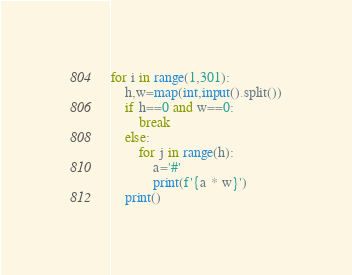<code> <loc_0><loc_0><loc_500><loc_500><_Python_>for i in range(1,301):
    h,w=map(int,input().split())
    if h==0 and w==0:
        break
    else:
        for j in range(h):
            a='#'
            print(f'{a * w}')
    print()
</code> 